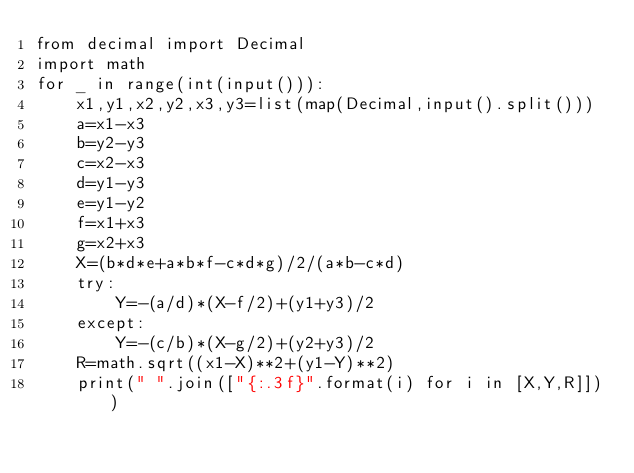<code> <loc_0><loc_0><loc_500><loc_500><_Python_>from decimal import Decimal
import math
for _ in range(int(input())):
    x1,y1,x2,y2,x3,y3=list(map(Decimal,input().split()))
    a=x1-x3
    b=y2-y3
    c=x2-x3
    d=y1-y3
    e=y1-y2
    f=x1+x3
    g=x2+x3
    X=(b*d*e+a*b*f-c*d*g)/2/(a*b-c*d)
    try:
        Y=-(a/d)*(X-f/2)+(y1+y3)/2
    except:
        Y=-(c/b)*(X-g/2)+(y2+y3)/2
    R=math.sqrt((x1-X)**2+(y1-Y)**2)
    print(" ".join(["{:.3f}".format(i) for i in [X,Y,R]]))
</code> 